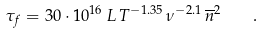Convert formula to latex. <formula><loc_0><loc_0><loc_500><loc_500>\tau _ { f } = 3 0 \cdot 1 0 ^ { 1 6 } \, L \, T ^ { - 1 . 3 5 } \, \nu ^ { - 2 . 1 } \, \overline { n } ^ { 2 } \quad .</formula> 